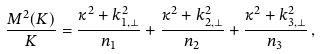<formula> <loc_0><loc_0><loc_500><loc_500>\frac { M ^ { 2 } ( K ) } { K } = \frac { \kappa ^ { 2 } + k ^ { 2 } _ { 1 , \perp } } { n _ { 1 } } + \frac { \kappa ^ { 2 } + k ^ { 2 } _ { 2 , \perp } } { n _ { 2 } } + \frac { \kappa ^ { 2 } + k ^ { 2 } _ { 3 , \perp } } { n _ { 3 } } \, ,</formula> 